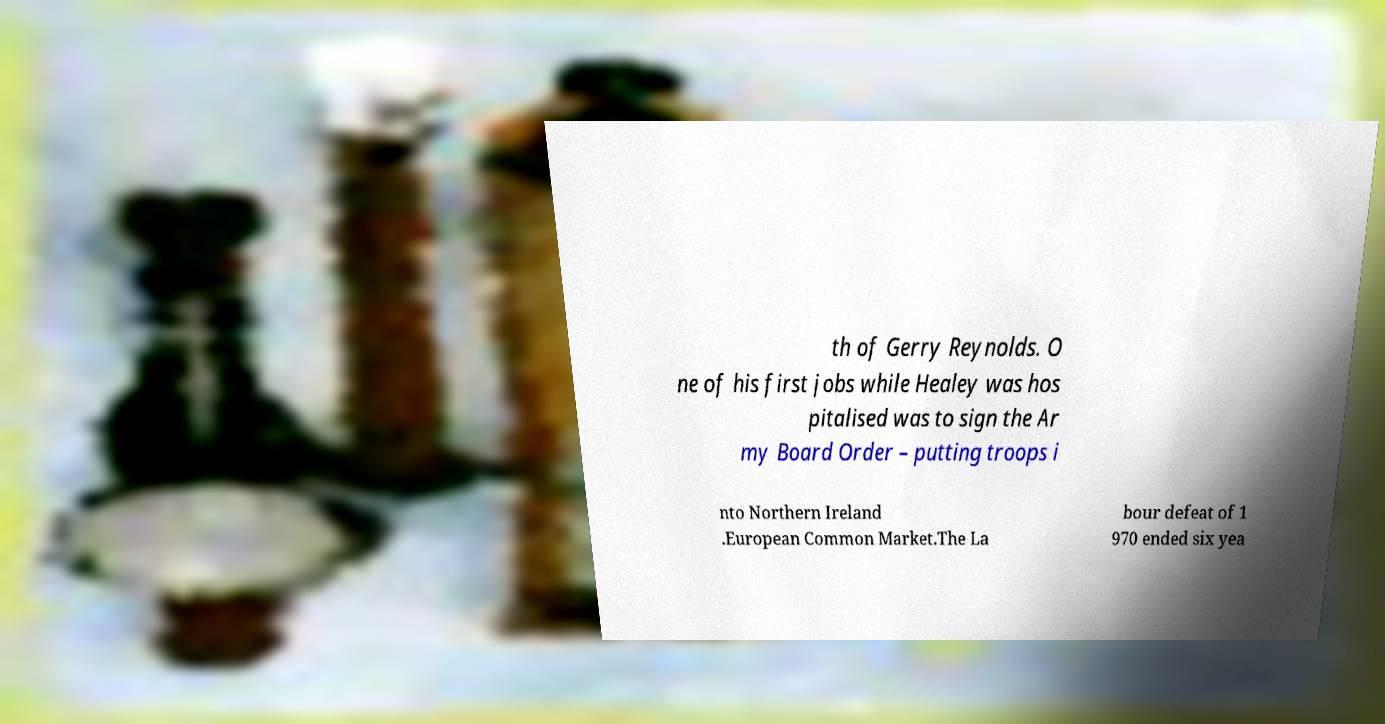There's text embedded in this image that I need extracted. Can you transcribe it verbatim? th of Gerry Reynolds. O ne of his first jobs while Healey was hos pitalised was to sign the Ar my Board Order – putting troops i nto Northern Ireland .European Common Market.The La bour defeat of 1 970 ended six yea 